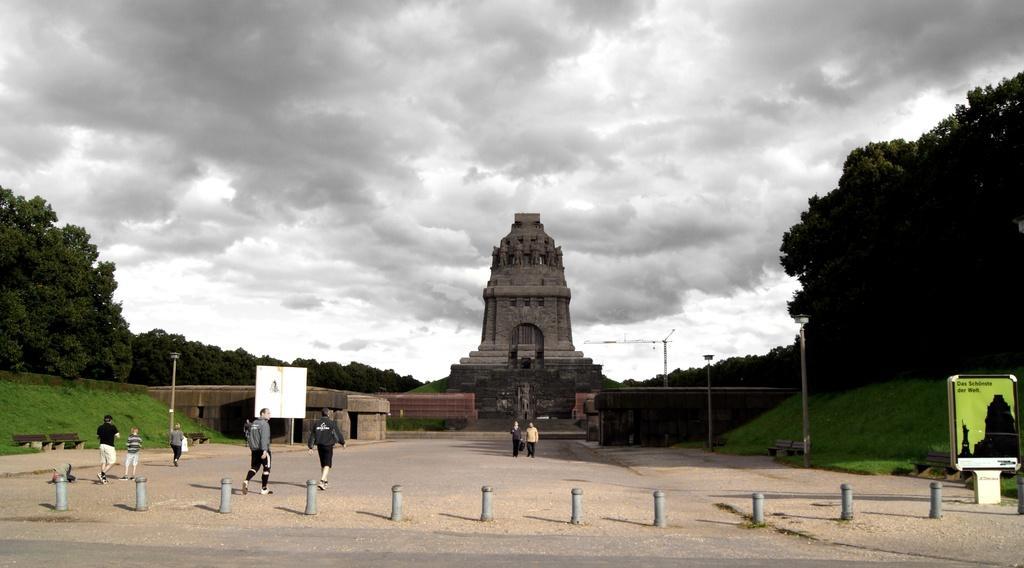In one or two sentences, can you explain what this image depicts? In the center of the image there is a monument. There are people walking on the road. To the both sides of the image there are trees. There is grass. At the bottom of the image there is road. 